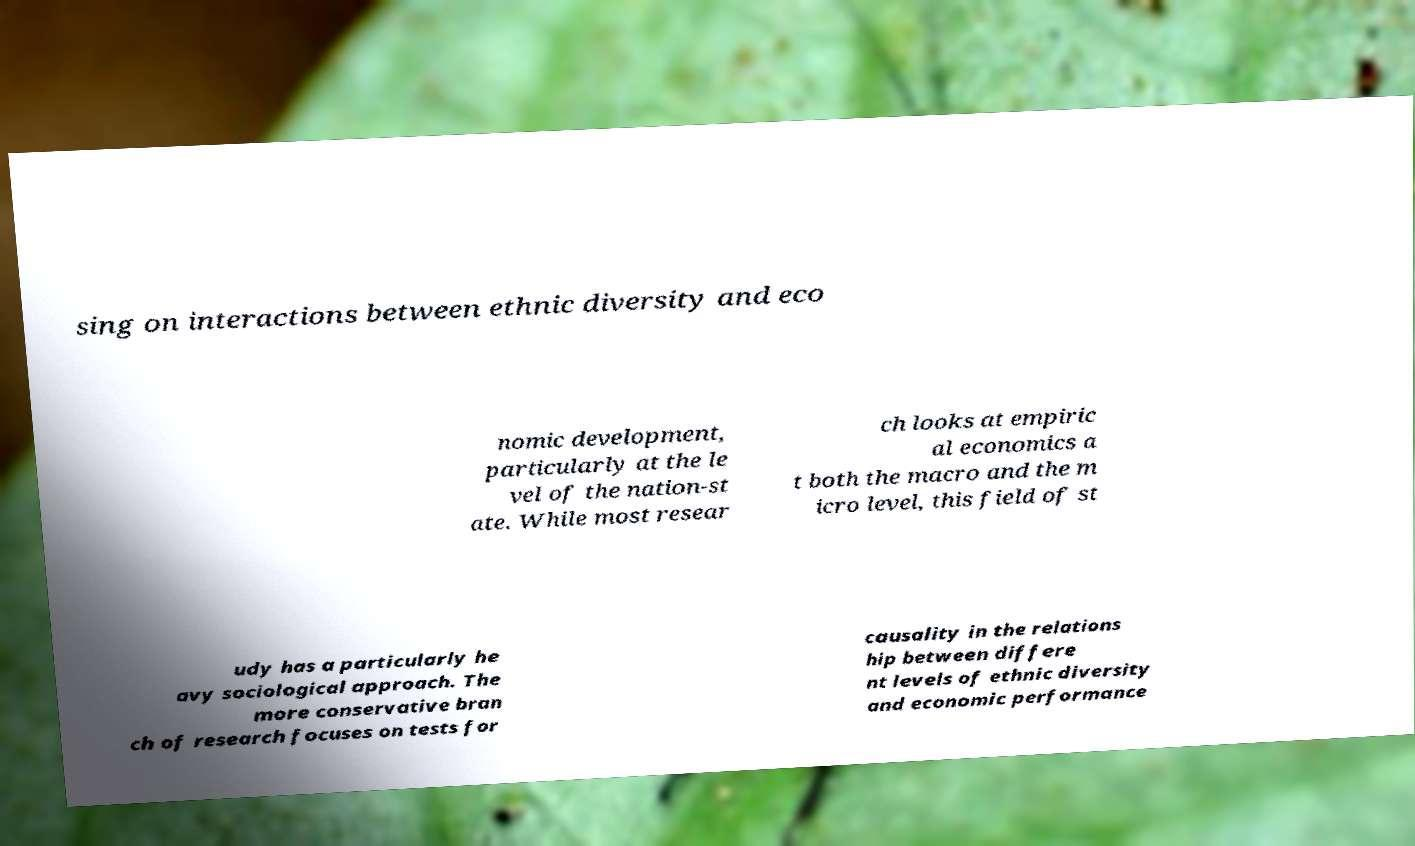I need the written content from this picture converted into text. Can you do that? sing on interactions between ethnic diversity and eco nomic development, particularly at the le vel of the nation-st ate. While most resear ch looks at empiric al economics a t both the macro and the m icro level, this field of st udy has a particularly he avy sociological approach. The more conservative bran ch of research focuses on tests for causality in the relations hip between differe nt levels of ethnic diversity and economic performance 